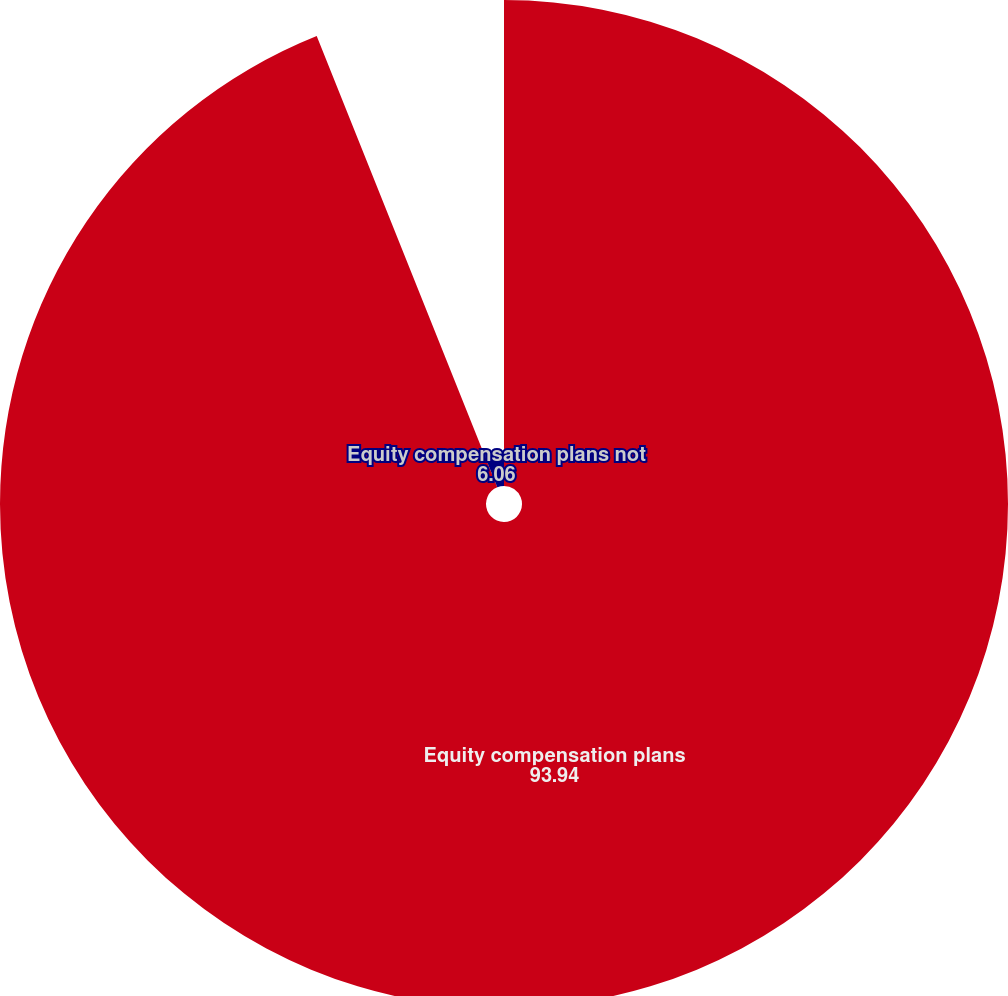Convert chart. <chart><loc_0><loc_0><loc_500><loc_500><pie_chart><fcel>Equity compensation plans<fcel>Equity compensation plans not<nl><fcel>93.94%<fcel>6.06%<nl></chart> 